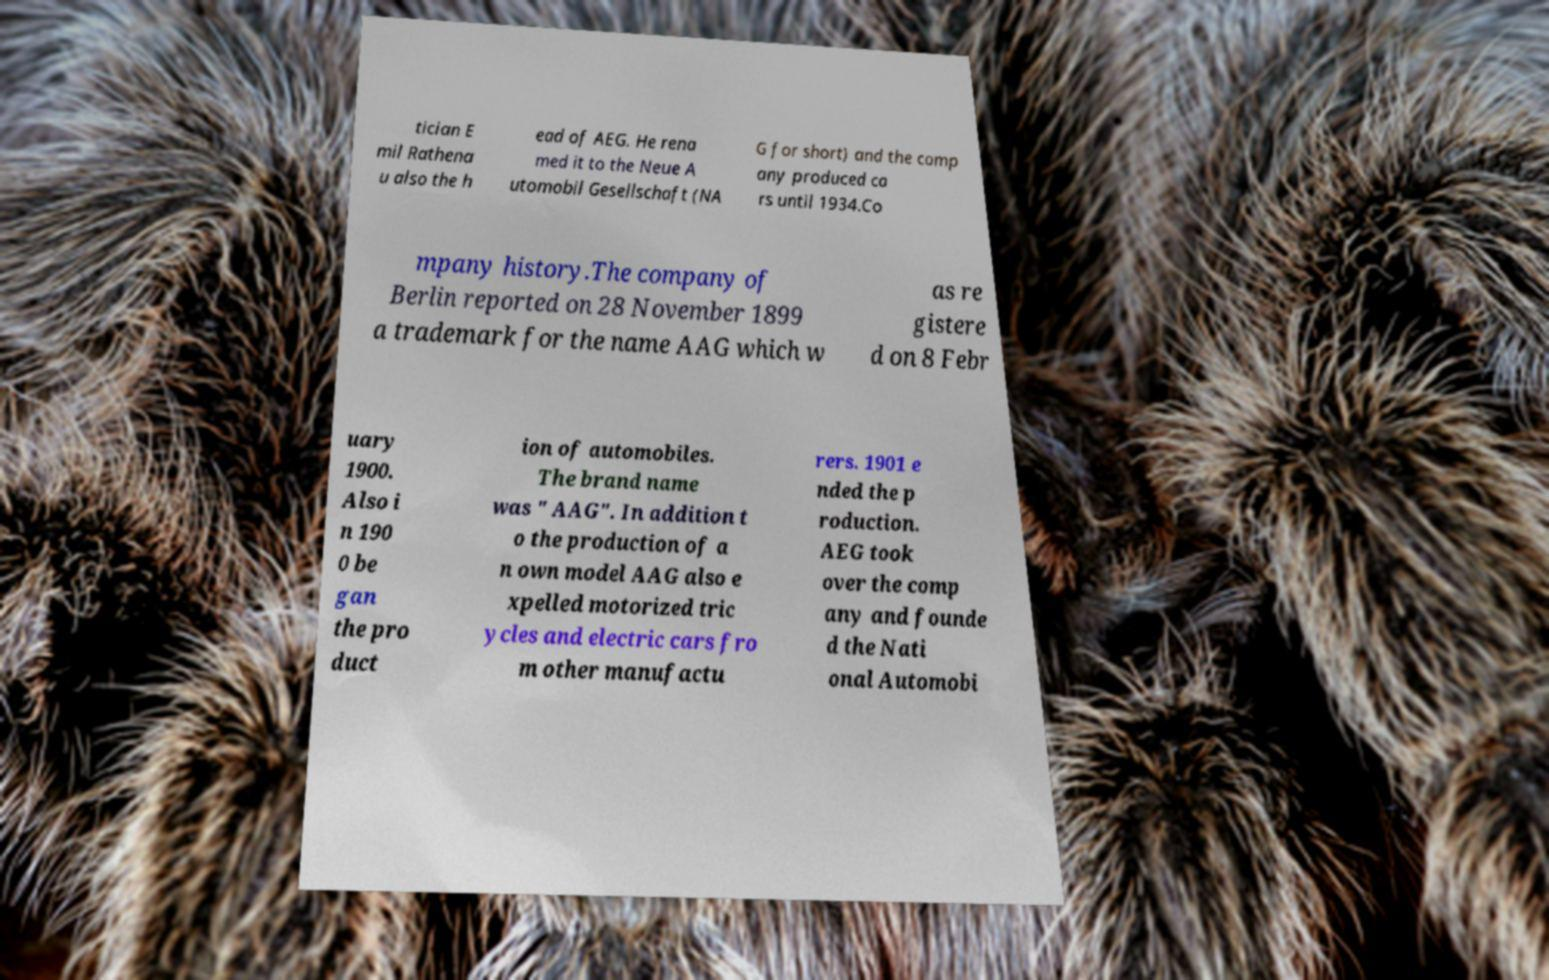Can you read and provide the text displayed in the image?This photo seems to have some interesting text. Can you extract and type it out for me? tician E mil Rathena u also the h ead of AEG. He rena med it to the Neue A utomobil Gesellschaft (NA G for short) and the comp any produced ca rs until 1934.Co mpany history.The company of Berlin reported on 28 November 1899 a trademark for the name AAG which w as re gistere d on 8 Febr uary 1900. Also i n 190 0 be gan the pro duct ion of automobiles. The brand name was " AAG". In addition t o the production of a n own model AAG also e xpelled motorized tric ycles and electric cars fro m other manufactu rers. 1901 e nded the p roduction. AEG took over the comp any and founde d the Nati onal Automobi 